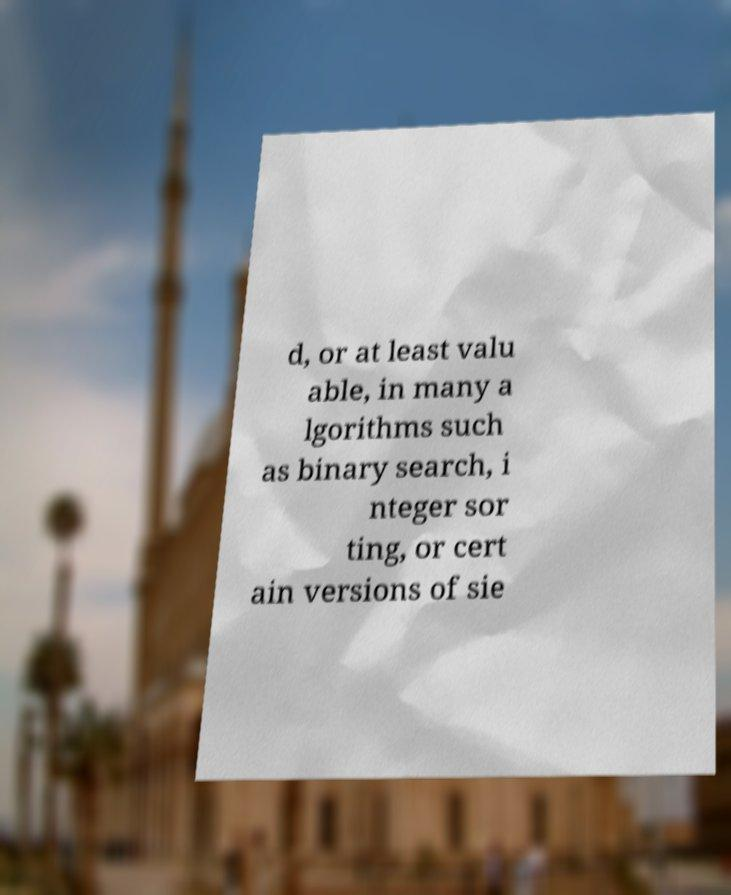What messages or text are displayed in this image? I need them in a readable, typed format. d, or at least valu able, in many a lgorithms such as binary search, i nteger sor ting, or cert ain versions of sie 